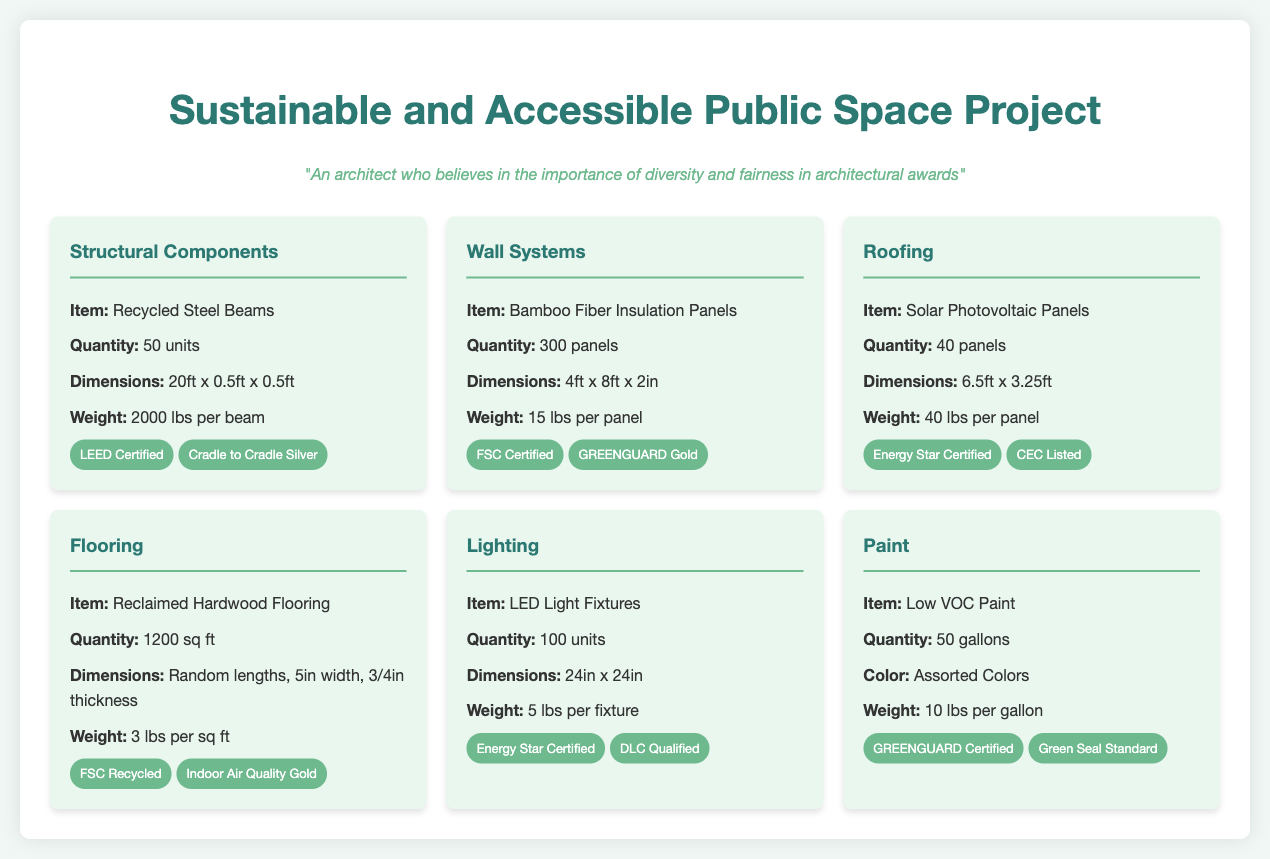What is the quantity of Recycled Steel Beams? The document states that there are 50 units of Recycled Steel Beams listed.
Answer: 50 units What certification label does the Bamboo Fiber Insulation Panels have? The document lists that the Bamboo Fiber Insulation Panels are FSC Certified.
Answer: FSC Certified What is the weight of one Solar Photovoltaic Panel? According to the document, each Solar Photovoltaic Panel weighs 40 lbs.
Answer: 40 lbs What is the total area of Reclaimed Hardwood Flooring? The document indicates that there are 1200 sq ft of Reclaimed Hardwood Flooring.
Answer: 1200 sq ft How many LED Light Fixtures are included in the shipment? The document specifies that there are 100 units of LED Light Fixtures.
Answer: 100 units Which certification label applies to the Low VOC Paint? The document states that the Low VOC Paint is GREENGUARD Certified.
Answer: GREENGUARD Certified What is the weight of the Bamboo Fiber Insulation Panel? The document mentions that each Bamboo Fiber Insulation Panel weighs 15 lbs.
Answer: 15 lbs What are the dimensions of the Recycled Steel Beams? The dimensions of the Recycled Steel Beams are 20ft x 0.5ft x 0.5ft as listed in the document.
Answer: 20ft x 0.5ft x 0.5ft Which component has the most certification labels listed? The document shows that the Reclaimed Hardwood Flooring has two certification labels (FSC Recycled and Indoor Air Quality Gold).
Answer: Reclaimed Hardwood Flooring 